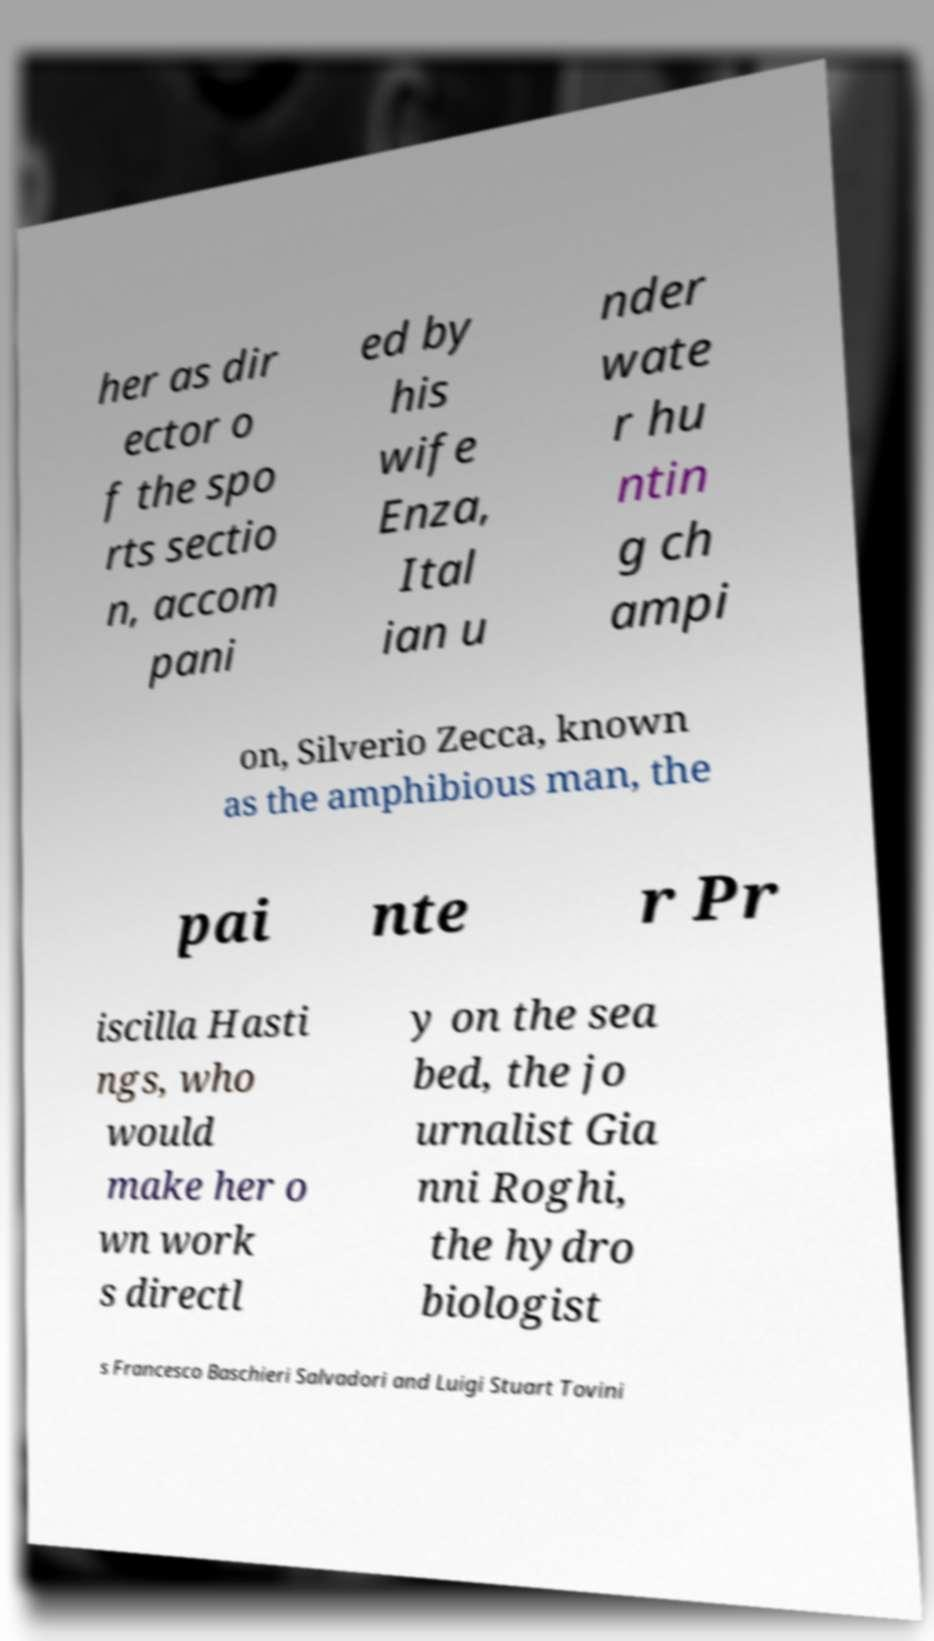Can you read and provide the text displayed in the image?This photo seems to have some interesting text. Can you extract and type it out for me? her as dir ector o f the spo rts sectio n, accom pani ed by his wife Enza, Ital ian u nder wate r hu ntin g ch ampi on, Silverio Zecca, known as the amphibious man, the pai nte r Pr iscilla Hasti ngs, who would make her o wn work s directl y on the sea bed, the jo urnalist Gia nni Roghi, the hydro biologist s Francesco Baschieri Salvadori and Luigi Stuart Tovini 